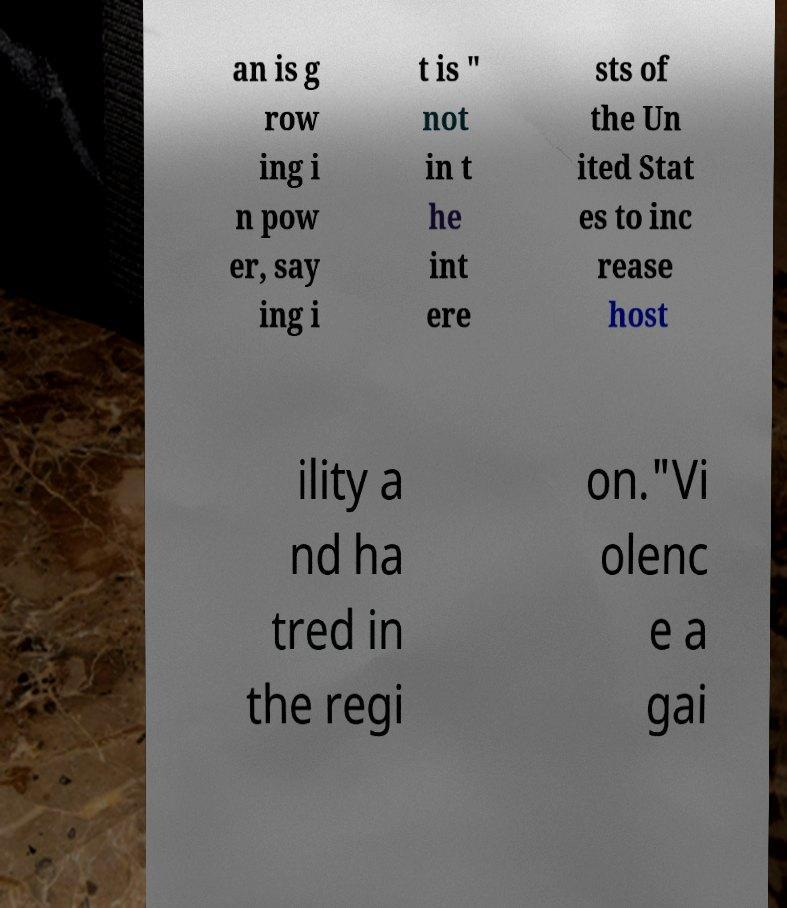Please identify and transcribe the text found in this image. an is g row ing i n pow er, say ing i t is " not in t he int ere sts of the Un ited Stat es to inc rease host ility a nd ha tred in the regi on."Vi olenc e a gai 